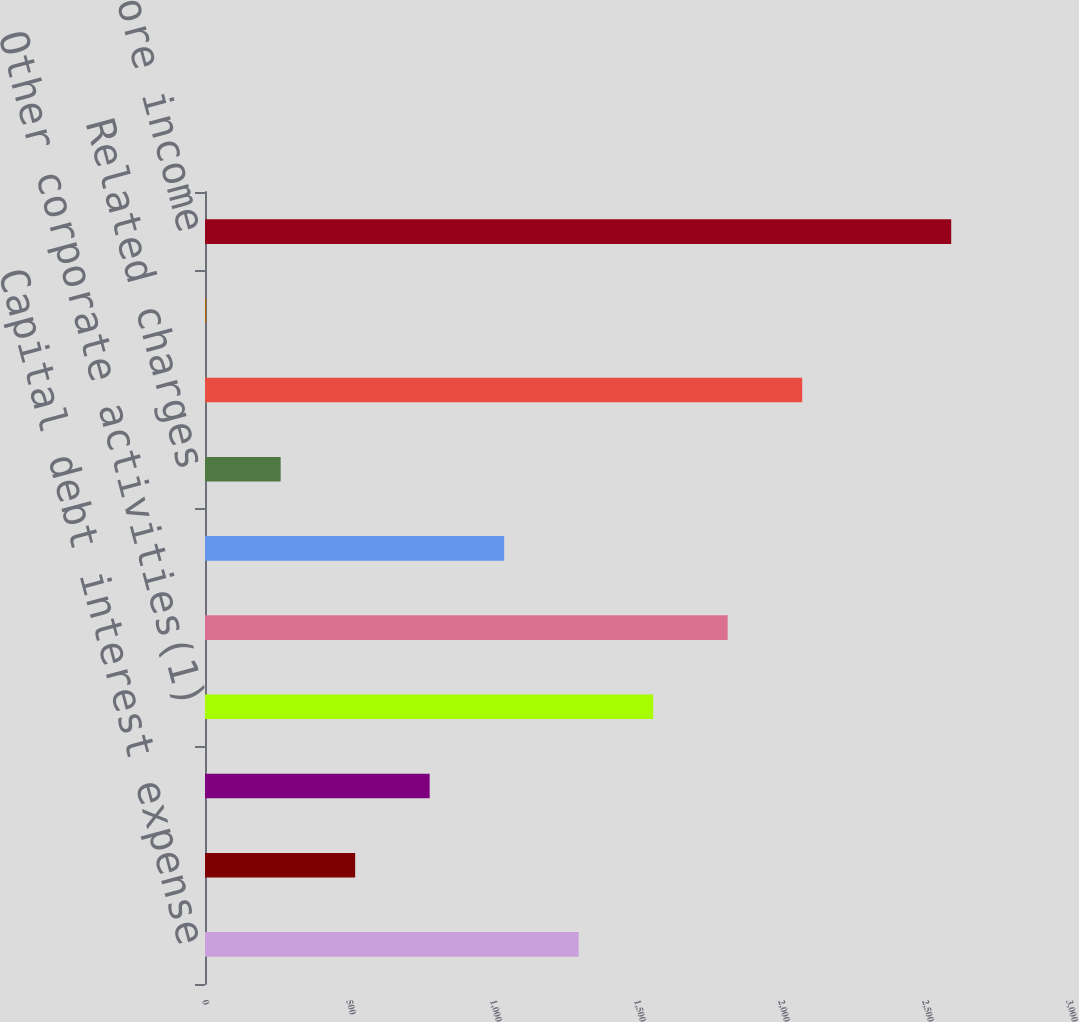Convert chart. <chart><loc_0><loc_0><loc_500><loc_500><bar_chart><fcel>Capital debt interest expense<fcel>Investment income net of<fcel>Pension and employee benefits<fcel>Other corporate activities(1)<fcel>Adjusted operating income<fcel>Realized investment gains<fcel>Related charges<fcel>Divested and Run-off<fcel>Unnamed: 8<fcel>Income (loss) before income<nl><fcel>1297.5<fcel>521.4<fcel>780.1<fcel>1556.2<fcel>1814.9<fcel>1038.8<fcel>262.7<fcel>2073.6<fcel>4<fcel>2591<nl></chart> 